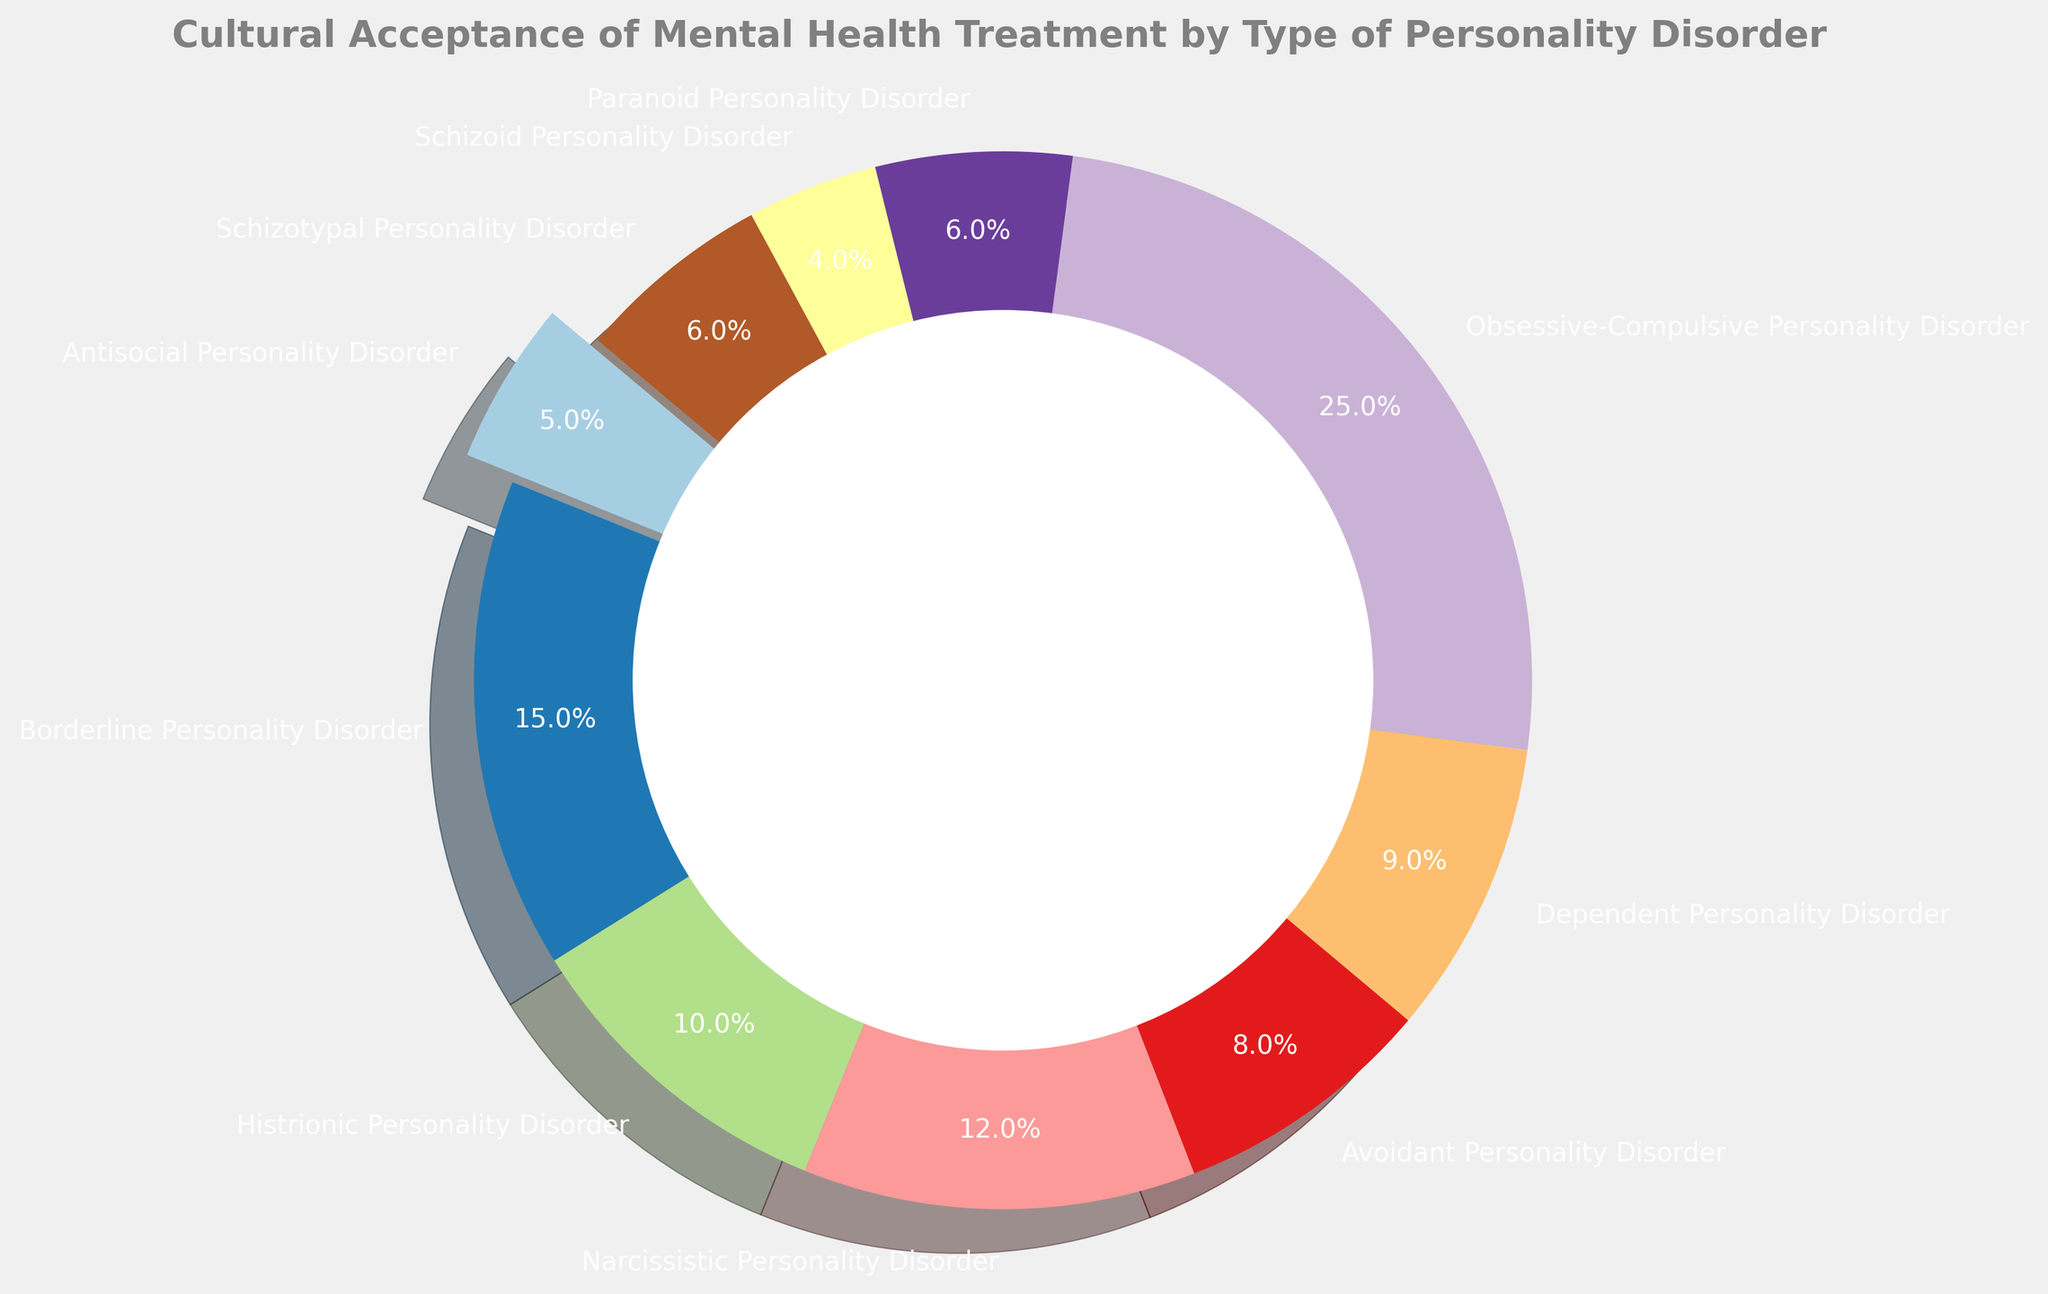What type of personality disorder has the highest cultural acceptance of mental health treatment? To determine the type of personality disorder with the highest cultural acceptance, look at the percentage values associated with each disorder and identify the largest one. Here, Obsessive-Compulsive Personality Disorder has the highest acceptance at 25%.
Answer: Obsessive-Compulsive Personality Disorder Which types of personality disorders have acceptance percentages below 10%? Identify the disorders with percentages below 10%. These are Antisocial (5%), Avoidant (8%), Dependent (9%), Paranoid (6%), Schizoid (4%), and Schizotypal (6%).
Answer: Antisocial, Avoidant, Dependent, Paranoid, Schizoid, Schizotypal Is cultural acceptance higher for Borderline or Narcissistic Personality Disorder? Compare the acceptance percentages for these disorders. Borderline is 15%, while Narcissistic is 12%. Thus, acceptance is higher for Borderline.
Answer: Borderline Personality Disorder What is the total cultural acceptance percentage for Antisocial, Paranoid, and Schizoid Personality Disorders combined? Sum the percentages for these disorders: Antisocial (5%) + Paranoid (6%) + Schizoid (4%) = 15%.
Answer: 15% What's the difference in cultural acceptance between Histrionic and Avoidant Personality Disorders? Subtract the percentage of Avoidant from Histrionic: Histrionic (10%) - Avoidant (8%) = 2%.
Answer: 2% Which personality disorder section is slightly exploded in the pie chart? Check the visual representation of the pie chart, where one section is separated slightly more from the center than the others. The exploded section represents Antisocial Personality Disorder.
Answer: Antisocial Personality Disorder Compare the combined acceptance percentages of Cluster A disorders (Paranoid, Schizoid, Schizotypal) with Cluster B disorders (Antisocial, Borderline, Histrionic, Narcissistic). Which cluster has higher acceptance? Sum the percentages for Cluster A: Paranoid (6%) + Schizoid (4%) + Schizotypal (6%) = 16%. Sum for Cluster B: Antisocial (5%) + Borderline (15%) + Histrionic (10%) + Narcissistic (12%) = 42%. Cluster B has higher acceptance.
Answer: Cluster B What percentage of the chart represents the combined acceptance for Cluster C disorders (Avoidant, Dependent, Obsessive-Compulsive)? Sum the percentages for Cluster C: Avoidant (8%) + Dependent (9%) + Obsessive-Compulsive (25%) = 42%.
Answer: 42% 